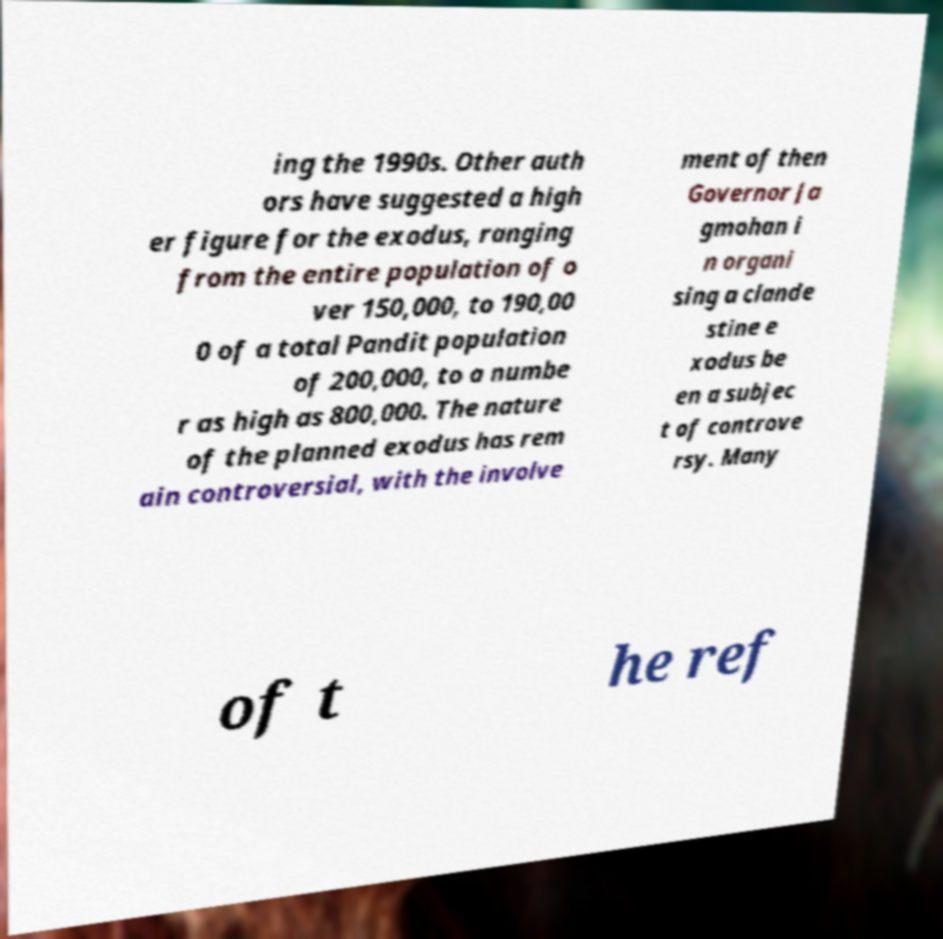Could you extract and type out the text from this image? ing the 1990s. Other auth ors have suggested a high er figure for the exodus, ranging from the entire population of o ver 150,000, to 190,00 0 of a total Pandit population of 200,000, to a numbe r as high as 800,000. The nature of the planned exodus has rem ain controversial, with the involve ment of then Governor Ja gmohan i n organi sing a clande stine e xodus be en a subjec t of controve rsy. Many of t he ref 